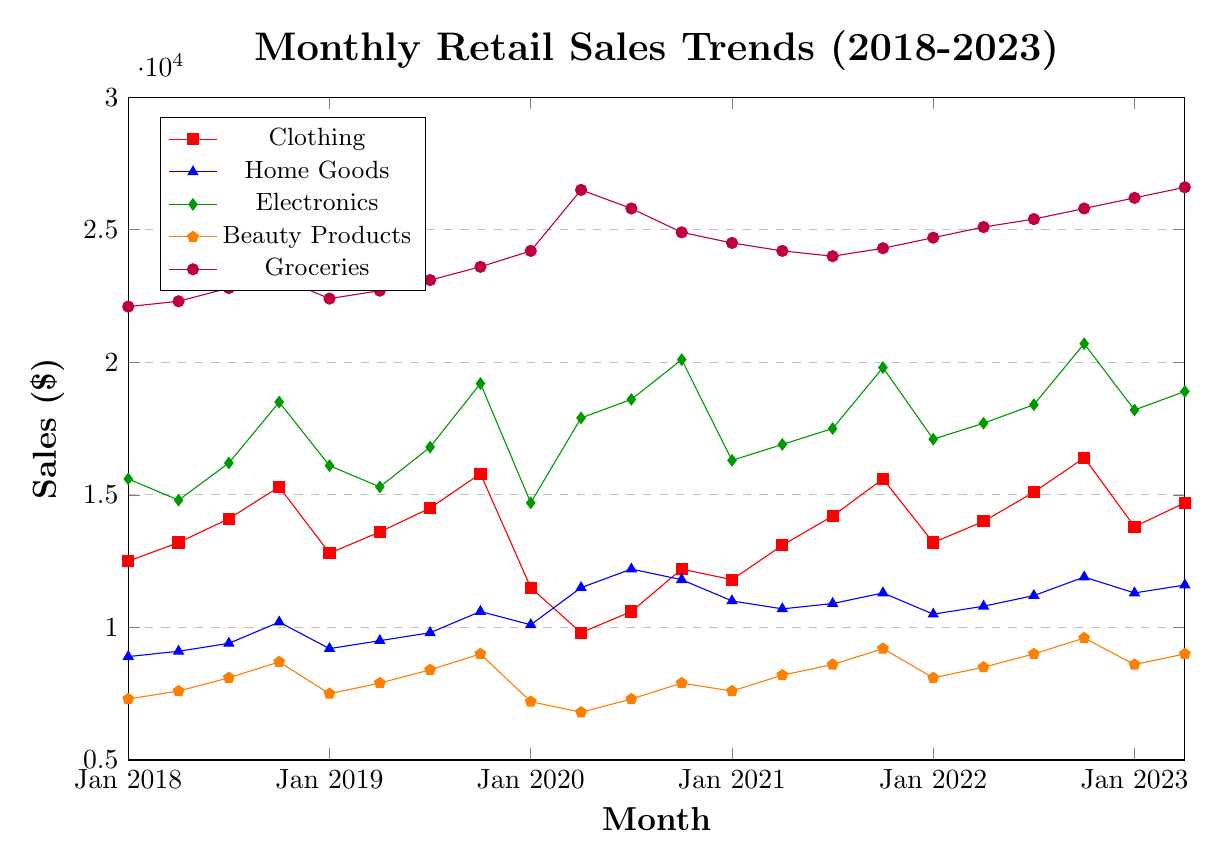What product category showed the highest sales in Jul 2020? To find the product category with the highest sales in Jul 2020, we locate the data points corresponding to Jul 2020 and compare them. Looking at the given coordinates, Groceries have the highest sales with 25800.
Answer: Groceries Which product had the steepest increase in sales from Apr 2019 to Apr 2020? To determine this, we look at the difference in sales for each product category between Apr 2019 and Apr 2020. Electronics increased from 15300 to 17900, the largest jump compared to other products over the same period.
Answer: Electronics How did the sales of Beauty Products change from Jan 2020 to Jul 2020? Referring to the data points, the sales of Beauty Products were 7200 in Jan 2020 and increased to 7300 in Jul 2020, indicating a small increase.
Answer: Increased slightly Compare the sales of Electronics and Home Goods in Oct 2022. Which one had higher sales, and by how much? The sales of Electronics in Oct 2022 were 20700, while Home Goods were 11900. The difference is 20700 - 11900.
Answer: Electronics by 8800 What is the overall trend of the Groceries category from 2018 to 2023? Observing the data points from Jan 2018 to Apr 2023, Groceries sales generally show an upward trend, starting at 22100 and increasing to 26600.
Answer: Upward trend Calculate the average monthly sales of Clothing in the year 2022. To find the average, sum the values for Jan, Apr, Jul, and Oct 2022, which are 13200, 14000, 15100, and 16400, respectively. Then divide by 4. (13200 + 14000 + 15100 + 16400) / 4.
Answer: 14675 Which product category experienced the least fluctuation in sales over the 5-year period? We look for the product with the least variation between minimum and maximum sales. Home Goods vary between 8900 and 12200, showing the smallest fluctuation.
Answer: Home Goods Which month had the lowest sales for Clothing, and what was the value? By examining the trend line for Clothing, the lowest point is in Apr 2020 with sales of 9800.
Answer: Apr 2020, 9800 How did the sales for Groceries change between Jan 2020 and Apr 2020? Sales for Groceries were 24200 in Jan 2020 and rose to 26500 in Apr 2020, indicating an increase.
Answer: Increased Compare the sales trend of Clothing and Electronics between Jan 2020 and Jul 2021. Between Jan 2020 and Jul 2021, Clothing sales dipped and then gradually increased, while Electronics saw an overall increase but had a steeper rise than Clothing.
Answer: Clothing fluctuated and increased; Electronics steadily increased 